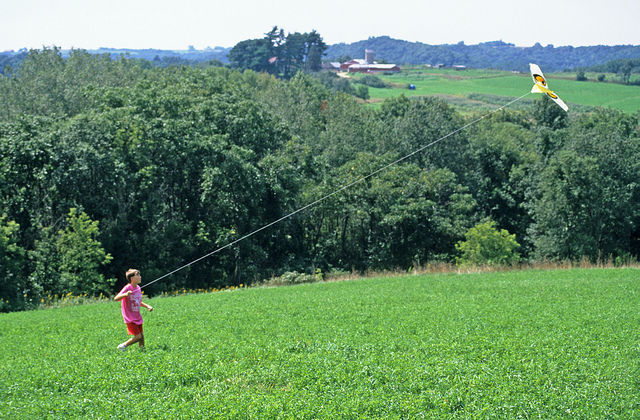How would you describe the location of the child? The child is situated on a picturesque grassy hill with a cluster of trees nearby. This scenic spot is located outside a town, providing a calm and serene environment. It’s a perfect setting for peaceful activities like kite flying, surrounded by nature's beauty. 